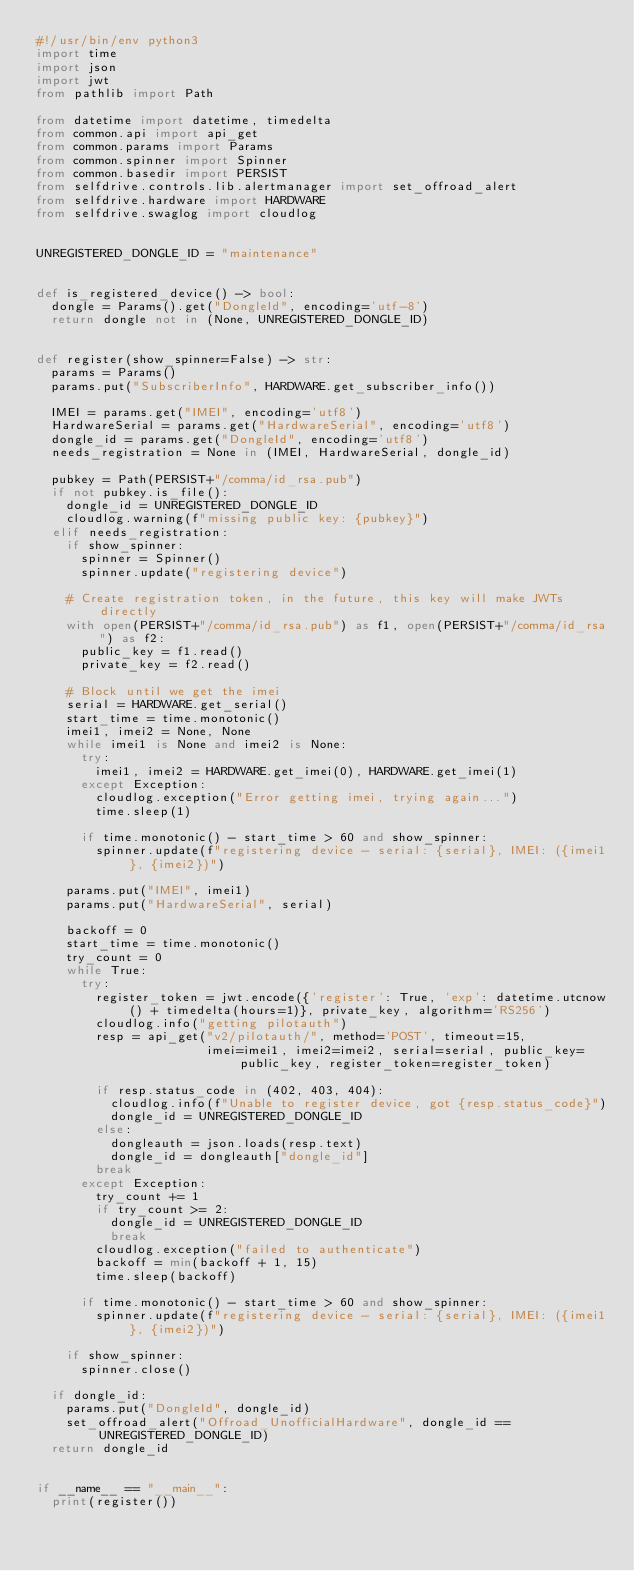<code> <loc_0><loc_0><loc_500><loc_500><_Python_>#!/usr/bin/env python3
import time
import json
import jwt
from pathlib import Path

from datetime import datetime, timedelta
from common.api import api_get
from common.params import Params
from common.spinner import Spinner
from common.basedir import PERSIST
from selfdrive.controls.lib.alertmanager import set_offroad_alert
from selfdrive.hardware import HARDWARE
from selfdrive.swaglog import cloudlog


UNREGISTERED_DONGLE_ID = "maintenance"


def is_registered_device() -> bool:
  dongle = Params().get("DongleId", encoding='utf-8')
  return dongle not in (None, UNREGISTERED_DONGLE_ID)


def register(show_spinner=False) -> str:
  params = Params()
  params.put("SubscriberInfo", HARDWARE.get_subscriber_info())

  IMEI = params.get("IMEI", encoding='utf8')
  HardwareSerial = params.get("HardwareSerial", encoding='utf8')
  dongle_id = params.get("DongleId", encoding='utf8')
  needs_registration = None in (IMEI, HardwareSerial, dongle_id)

  pubkey = Path(PERSIST+"/comma/id_rsa.pub")
  if not pubkey.is_file():
    dongle_id = UNREGISTERED_DONGLE_ID
    cloudlog.warning(f"missing public key: {pubkey}")
  elif needs_registration:
    if show_spinner:
      spinner = Spinner()
      spinner.update("registering device")

    # Create registration token, in the future, this key will make JWTs directly
    with open(PERSIST+"/comma/id_rsa.pub") as f1, open(PERSIST+"/comma/id_rsa") as f2:
      public_key = f1.read()
      private_key = f2.read()

    # Block until we get the imei
    serial = HARDWARE.get_serial()
    start_time = time.monotonic()
    imei1, imei2 = None, None
    while imei1 is None and imei2 is None:
      try:
        imei1, imei2 = HARDWARE.get_imei(0), HARDWARE.get_imei(1)
      except Exception:
        cloudlog.exception("Error getting imei, trying again...")
        time.sleep(1)

      if time.monotonic() - start_time > 60 and show_spinner:
        spinner.update(f"registering device - serial: {serial}, IMEI: ({imei1}, {imei2})")

    params.put("IMEI", imei1)
    params.put("HardwareSerial", serial)

    backoff = 0
    start_time = time.monotonic()
    try_count = 0
    while True:
      try:
        register_token = jwt.encode({'register': True, 'exp': datetime.utcnow() + timedelta(hours=1)}, private_key, algorithm='RS256')
        cloudlog.info("getting pilotauth")
        resp = api_get("v2/pilotauth/", method='POST', timeout=15,
                       imei=imei1, imei2=imei2, serial=serial, public_key=public_key, register_token=register_token)

        if resp.status_code in (402, 403, 404):
          cloudlog.info(f"Unable to register device, got {resp.status_code}")
          dongle_id = UNREGISTERED_DONGLE_ID
        else:
          dongleauth = json.loads(resp.text)
          dongle_id = dongleauth["dongle_id"]
        break
      except Exception:
        try_count += 1
        if try_count >= 2:
          dongle_id = UNREGISTERED_DONGLE_ID
          break
        cloudlog.exception("failed to authenticate")
        backoff = min(backoff + 1, 15)
        time.sleep(backoff)

      if time.monotonic() - start_time > 60 and show_spinner:
        spinner.update(f"registering device - serial: {serial}, IMEI: ({imei1}, {imei2})")

    if show_spinner:
      spinner.close()

  if dongle_id:
    params.put("DongleId", dongle_id)
    set_offroad_alert("Offroad_UnofficialHardware", dongle_id == UNREGISTERED_DONGLE_ID)
  return dongle_id


if __name__ == "__main__":
  print(register())
</code> 